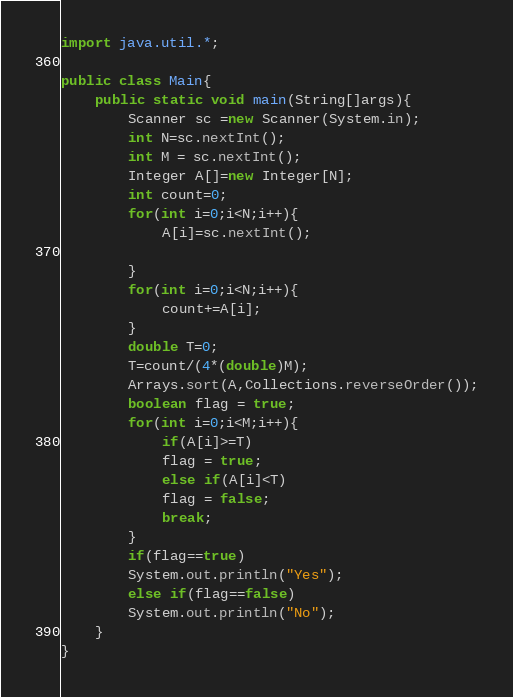<code> <loc_0><loc_0><loc_500><loc_500><_Java_>import java.util.*;

public class Main{
    public static void main(String[]args){
        Scanner sc =new Scanner(System.in);
        int N=sc.nextInt();
        int M = sc.nextInt();
        Integer A[]=new Integer[N];
        int count=0;
        for(int i=0;i<N;i++){
            A[i]=sc.nextInt();
        
        }
        for(int i=0;i<N;i++){
            count+=A[i];
        }
        double T=0;
        T=count/(4*(double)M);
        Arrays.sort(A,Collections.reverseOrder());
        boolean flag = true;
        for(int i=0;i<M;i++){
            if(A[i]>=T)
            flag = true;
            else if(A[i]<T)
            flag = false;
            break;
        }
        if(flag==true)
        System.out.println("Yes");
        else if(flag==false)
        System.out.println("No");
    }
}</code> 